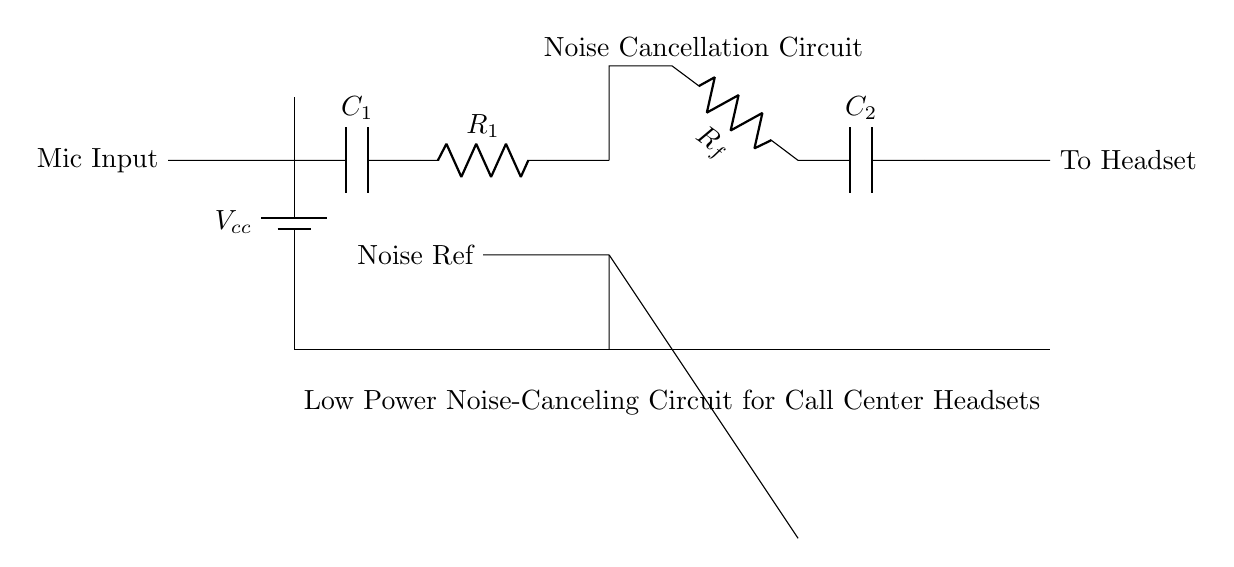What is the purpose of capacitor C1? Capacitor C1 is used to block DC voltage while allowing AC signals (audio signals) to pass, thus filtering the input from the microphone. This is a common practice to improve audio clarity.
Answer: Block DC voltage What type of amplifier is used in this circuit? An operational amplifier is employed in the circuit, which amplifies the difference between the input signals to enhance the audio quality for the headset.
Answer: Operational amplifier Where does the noise reference signal connect? The noise reference signal connects to the operational amplifier input at the point labeled "Noise Ref" to help in canceling unwanted background noise from the audio signal.
Answer: Noise Ref What is the function of resistor Rf? Resistor Rf is part of the feedback network that controls the gain of the operational amplifier, which adjusts how much the input signal is amplified before reaching the headset.
Answer: Gain control How many capacitors are present in the circuit? There are two capacitors in the circuit: C1 at the input stage and C2 at the output stage, each serving different filtering functions for the audio signal.
Answer: Two What is the output of this circuit connected to? The output of the circuit is connected to the headset, indicating that the processed audio signal will be sent to the user's ears for listening.
Answer: To Headset What does the circuit aim to improve for users? The circuit aims to improve call quality by canceling out background noise, providing a clearer audio experience for the users during calls.
Answer: Call quality 